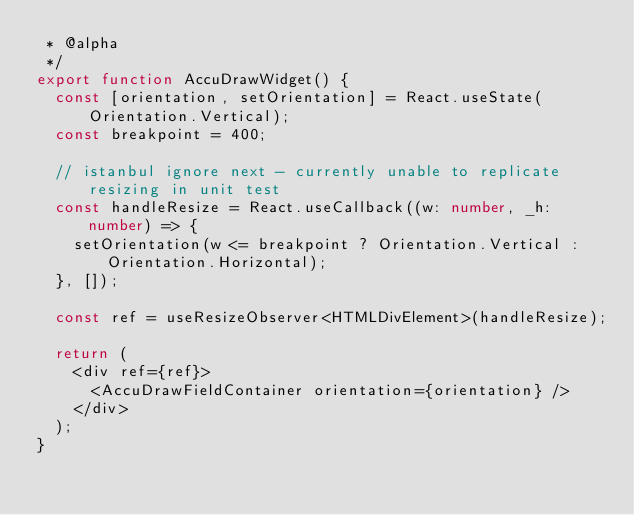<code> <loc_0><loc_0><loc_500><loc_500><_TypeScript_> * @alpha
 */
export function AccuDrawWidget() {
  const [orientation, setOrientation] = React.useState(Orientation.Vertical);
  const breakpoint = 400;

  // istanbul ignore next - currently unable to replicate resizing in unit test
  const handleResize = React.useCallback((w: number, _h: number) => {
    setOrientation(w <= breakpoint ? Orientation.Vertical : Orientation.Horizontal);
  }, []);

  const ref = useResizeObserver<HTMLDivElement>(handleResize);

  return (
    <div ref={ref}>
      <AccuDrawFieldContainer orientation={orientation} />
    </div>
  );
}
</code> 